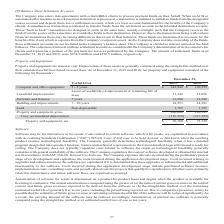According to Aci Worldwide's financial document, How was depreciation of the assets generally computed by the company? using the straight-line method over their estimated useful lives based on asset class.. The document states: "Depreciation of these assets is generally computed using the straight-line method over their estimated useful lives based on asset class. As of Decemb..." Also, What was the useful lives of Furniture and Fixtures? According to the financial document, 7 years. The relevant text states: "Furniture and fixtures 7 years 12,980 12,500..." Also, What was the cost of building and improvements in 2019? According to the financial document, 14,553 (in thousands). The relevant text states: "Building and improvements 7 - 30 years 14,553 14,381..." Also, can you calculate: What was the change in cost of furniture and fixtures between 2018 and 2019? Based on the calculation: 12,980-12,500, the result is 480 (in thousands). This is based on the information: "Furniture and fixtures 7 years 12,980 12,500 Furniture and fixtures 7 years 12,980 12,500..." The key data points involved are: 12,500, 12,980. Also, can you calculate: What was the change in the cost of computer and office equipment between 2018 and 2019? Based on the calculation: $143,942-$129,359, the result is 14583 (in thousands). This is based on the information: "Computer and office equipment 3 - 5 years $ 143,942 $ 129,359 uter and office equipment 3 - 5 years $ 143,942 $ 129,359..." The key data points involved are: 129,359, 143,942. Also, can you calculate: What was the percentage change in the cost of leasehold improvements lease between 2018 and 2019? To answer this question, I need to perform calculations using the financial data. The calculation is: (33,346-32,096)/32,096, which equals 3.89 (percentage). This is based on the information: "32,096 33,346..." The key data points involved are: 32,096, 33,346. 